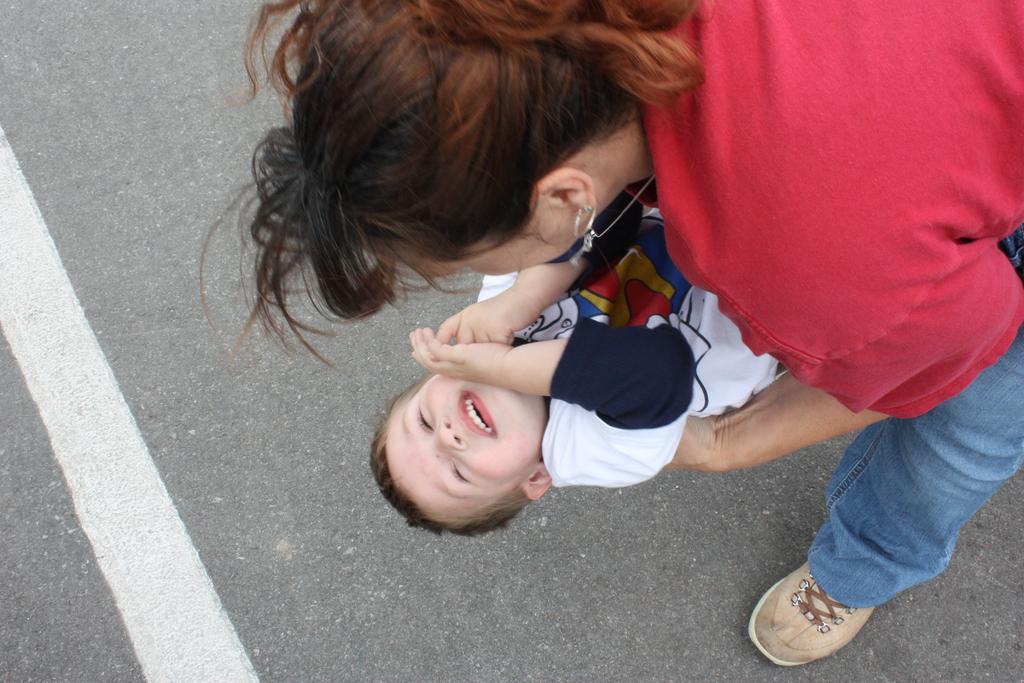Could you give a brief overview of what you see in this image? In the picture I can see the kid is wearing white color t-shirt and the woman is wearing red color top and blue jeans. The woman is standing on the road. On the road I can see white color line. 